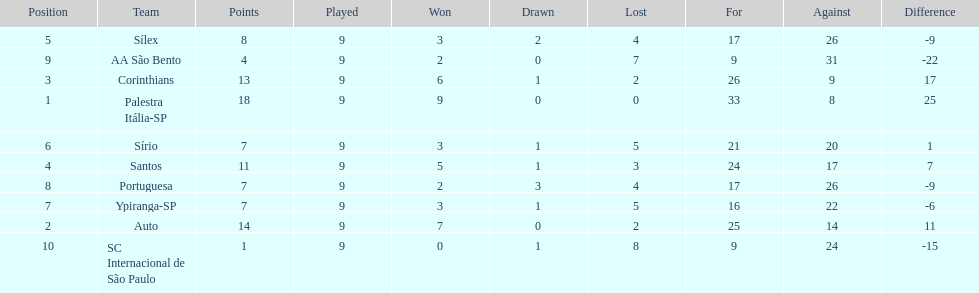How many teams had more points than silex? 4. 